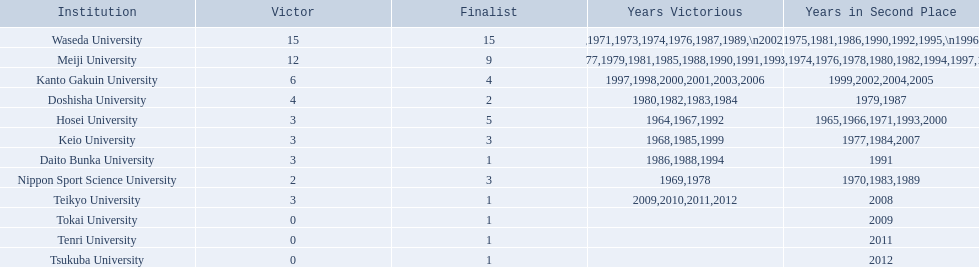Parse the table in full. {'header': ['Institution', 'Victor', 'Finalist', 'Years Victorious', 'Years in Second Place'], 'rows': [['Waseda University', '15', '15', '1965,1966,1968,1970,1971,1973,1974,1976,1987,1989,\\n2002,2004,2005,2007,2008', '1964,1967,1969,1972,1975,1981,1986,1990,1992,1995,\\n1996,2001,2003,2006,2010'], ['Meiji University', '12', '9', '1972,1975,1977,1979,1981,1985,1988,1990,1991,1993,\\n1995,1996', '1973,1974,1976,1978,1980,1982,1994,1997,1998'], ['Kanto Gakuin University', '6', '4', '1997,1998,2000,2001,2003,2006', '1999,2002,2004,2005'], ['Doshisha University', '4', '2', '1980,1982,1983,1984', '1979,1987'], ['Hosei University', '3', '5', '1964,1967,1992', '1965,1966,1971,1993,2000'], ['Keio University', '3', '3', '1968,1985,1999', '1977,1984,2007'], ['Daito Bunka University', '3', '1', '1986,1988,1994', '1991'], ['Nippon Sport Science University', '2', '3', '1969,1978', '1970,1983,1989'], ['Teikyo University', '3', '1', '2009,2010,2011,2012', '2008'], ['Tokai University', '0', '1', '', '2009'], ['Tenri University', '0', '1', '', '2011'], ['Tsukuba University', '0', '1', '', '2012']]} What university were there in the all-japan university rugby championship? Waseda University, Meiji University, Kanto Gakuin University, Doshisha University, Hosei University, Keio University, Daito Bunka University, Nippon Sport Science University, Teikyo University, Tokai University, Tenri University, Tsukuba University. Of these who had more than 12 wins? Waseda University. 